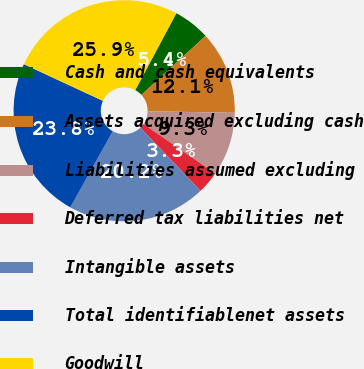Convert chart to OTSL. <chart><loc_0><loc_0><loc_500><loc_500><pie_chart><fcel>Cash and cash equivalents<fcel>Assets acquired excluding cash<fcel>Liabilities assumed excluding<fcel>Deferred tax liabilities net<fcel>Intangible assets<fcel>Total identifiablenet assets<fcel>Goodwill<nl><fcel>5.35%<fcel>12.13%<fcel>9.3%<fcel>3.28%<fcel>20.22%<fcel>23.82%<fcel>25.89%<nl></chart> 